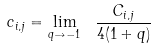<formula> <loc_0><loc_0><loc_500><loc_500>c _ { i , j } = \lim _ { q \to - 1 } \ \frac { C _ { i , j } } { 4 ( 1 + q ) }</formula> 